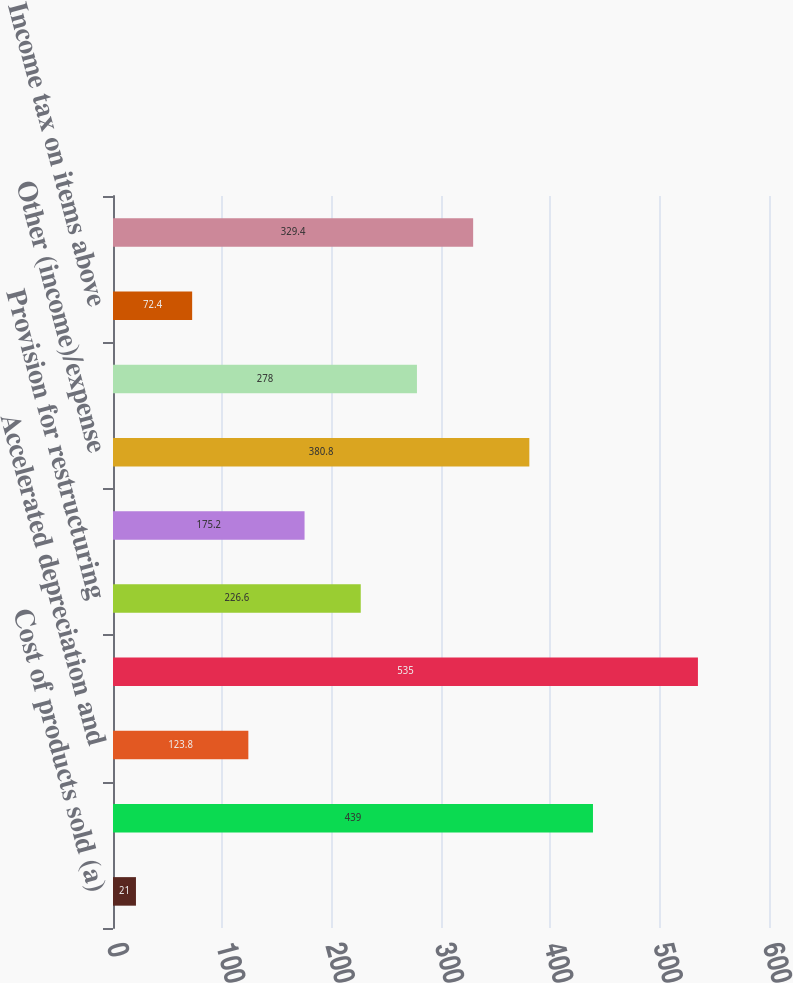<chart> <loc_0><loc_0><loc_500><loc_500><bar_chart><fcel>Cost of products sold (a)<fcel>License and asset acquisition<fcel>Accelerated depreciation and<fcel>Research and development<fcel>Provision for restructuring<fcel>Pension charges<fcel>Other (income)/expense<fcel>Increase/(decrease) to pretax<fcel>Income tax on items above<fcel>Increase/(decrease) to net<nl><fcel>21<fcel>439<fcel>123.8<fcel>535<fcel>226.6<fcel>175.2<fcel>380.8<fcel>278<fcel>72.4<fcel>329.4<nl></chart> 